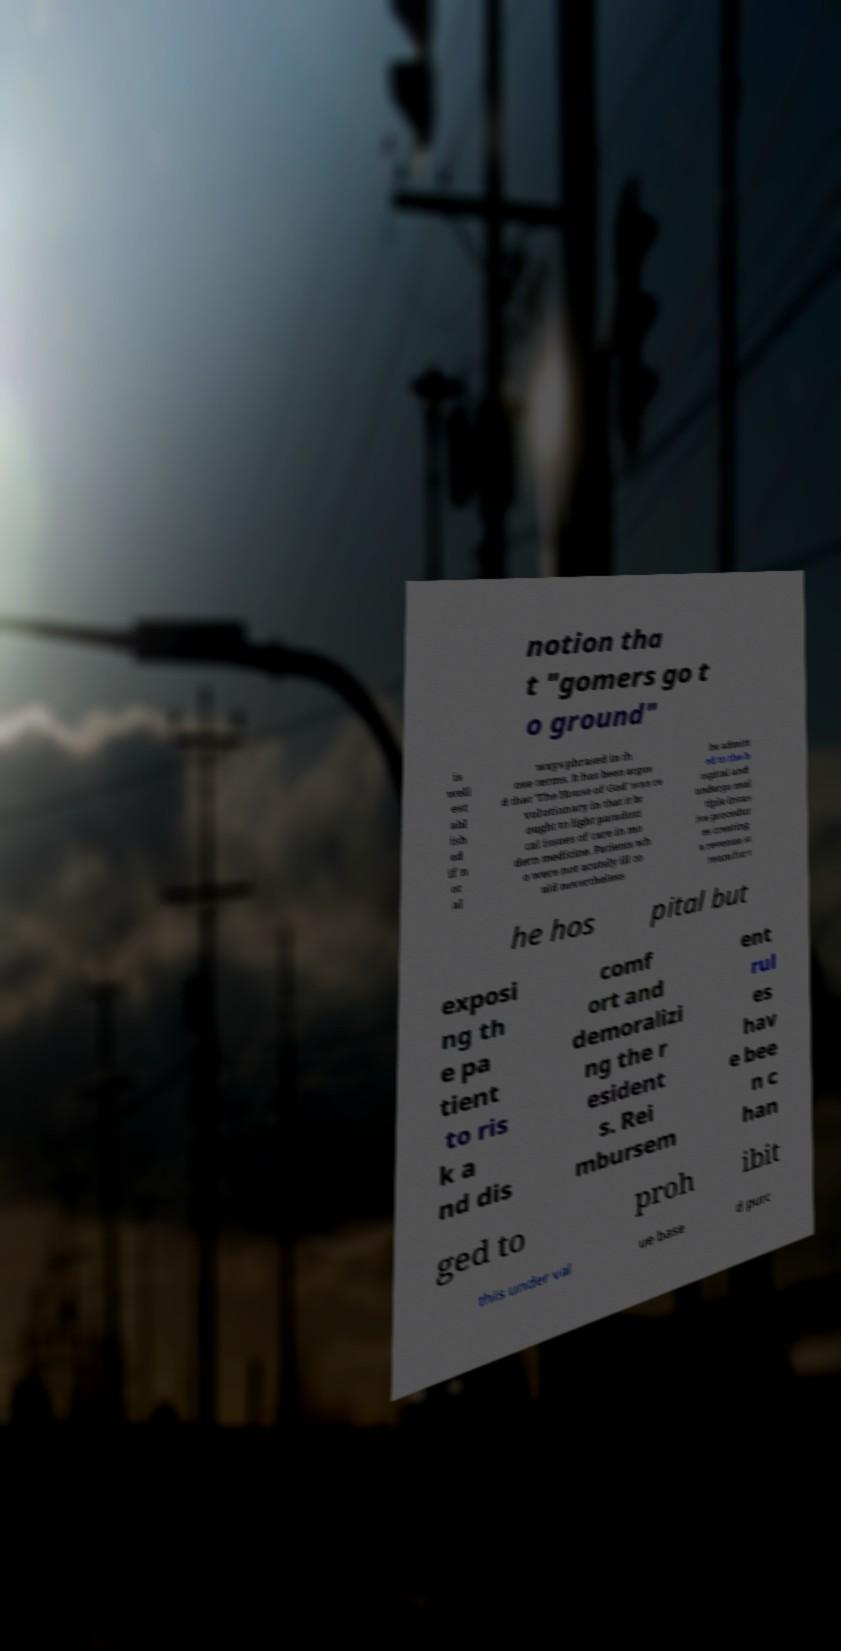I need the written content from this picture converted into text. Can you do that? notion tha t "gomers go t o ground" is well est abl ish ed if n ot al ways phrased in th ose terms. It has been argue d that 'The House of God' was re volutionary in that it br ought to light paradoxi cal issues of care in mo dern medicine. Patients wh o were not acutely ill co uld nevertheless be admitt ed to the h ospital and undergo mul tiple invas ive procedur es creating a revenue st ream for t he hos pital but exposi ng th e pa tient to ris k a nd dis comf ort and demoralizi ng the r esident s. Rei mbursem ent rul es hav e bee n c han ged to proh ibit this under val ue base d purc 